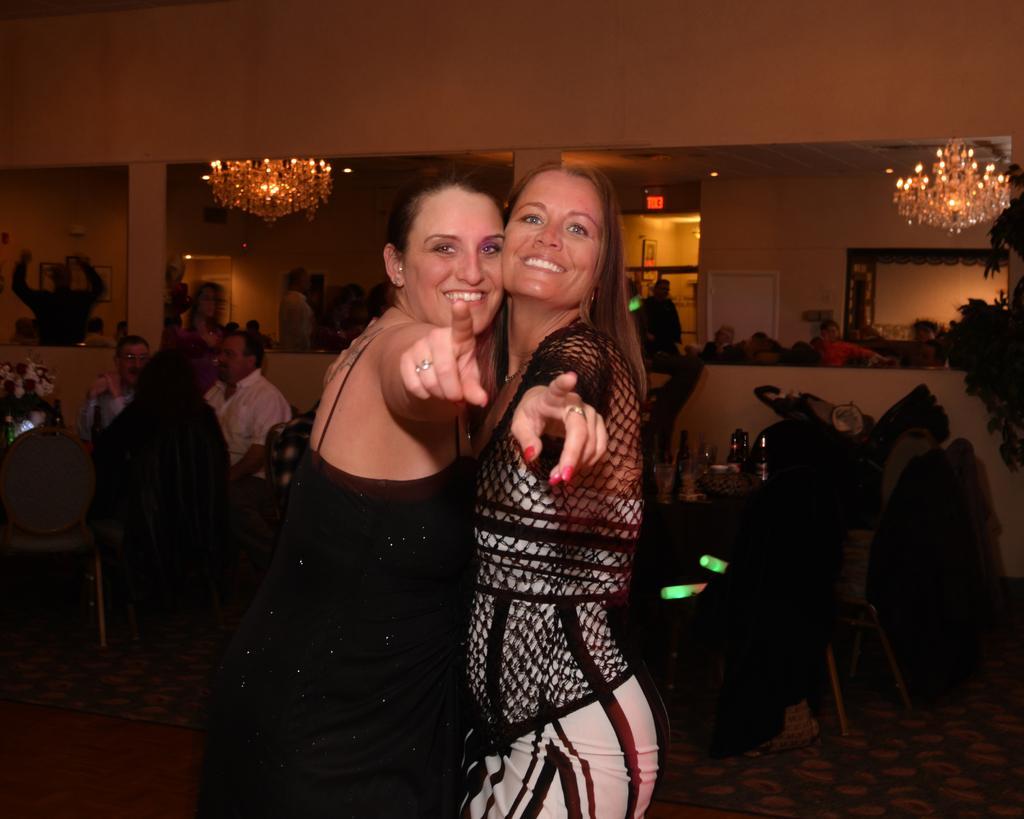How would you summarize this image in a sentence or two? In this image I can see a woman wearing black colored dress and another woman wearing black and white colored dress are standing and smiling. In the background I can see few other persons sitting on chairs, a table and few bottles and few glasses on the table, two chandeliers and few other objects. 